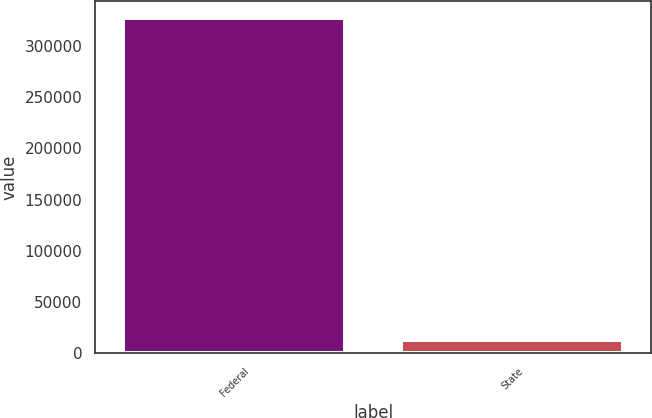Convert chart to OTSL. <chart><loc_0><loc_0><loc_500><loc_500><bar_chart><fcel>Federal<fcel>State<nl><fcel>327131<fcel>12786<nl></chart> 